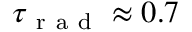<formula> <loc_0><loc_0><loc_500><loc_500>\tau _ { r a d } \approx 0 . 7</formula> 